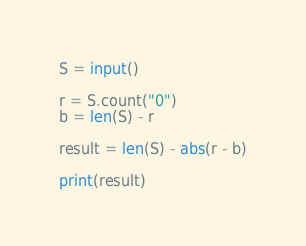Convert code to text. <code><loc_0><loc_0><loc_500><loc_500><_Python_>S = input()

r = S.count("0")
b = len(S) - r

result = len(S) - abs(r - b)

print(result)</code> 